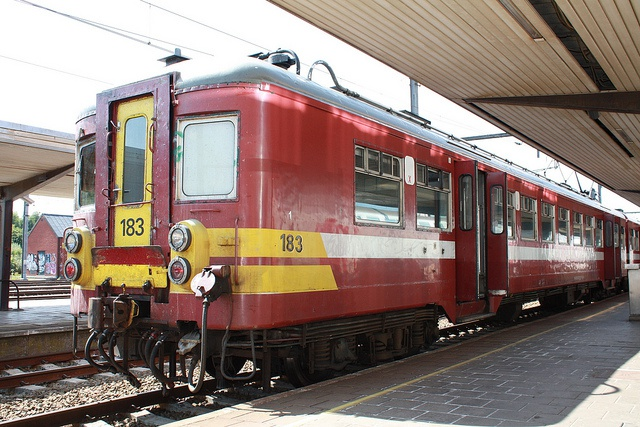Describe the objects in this image and their specific colors. I can see a train in white, black, maroon, brown, and lightgray tones in this image. 